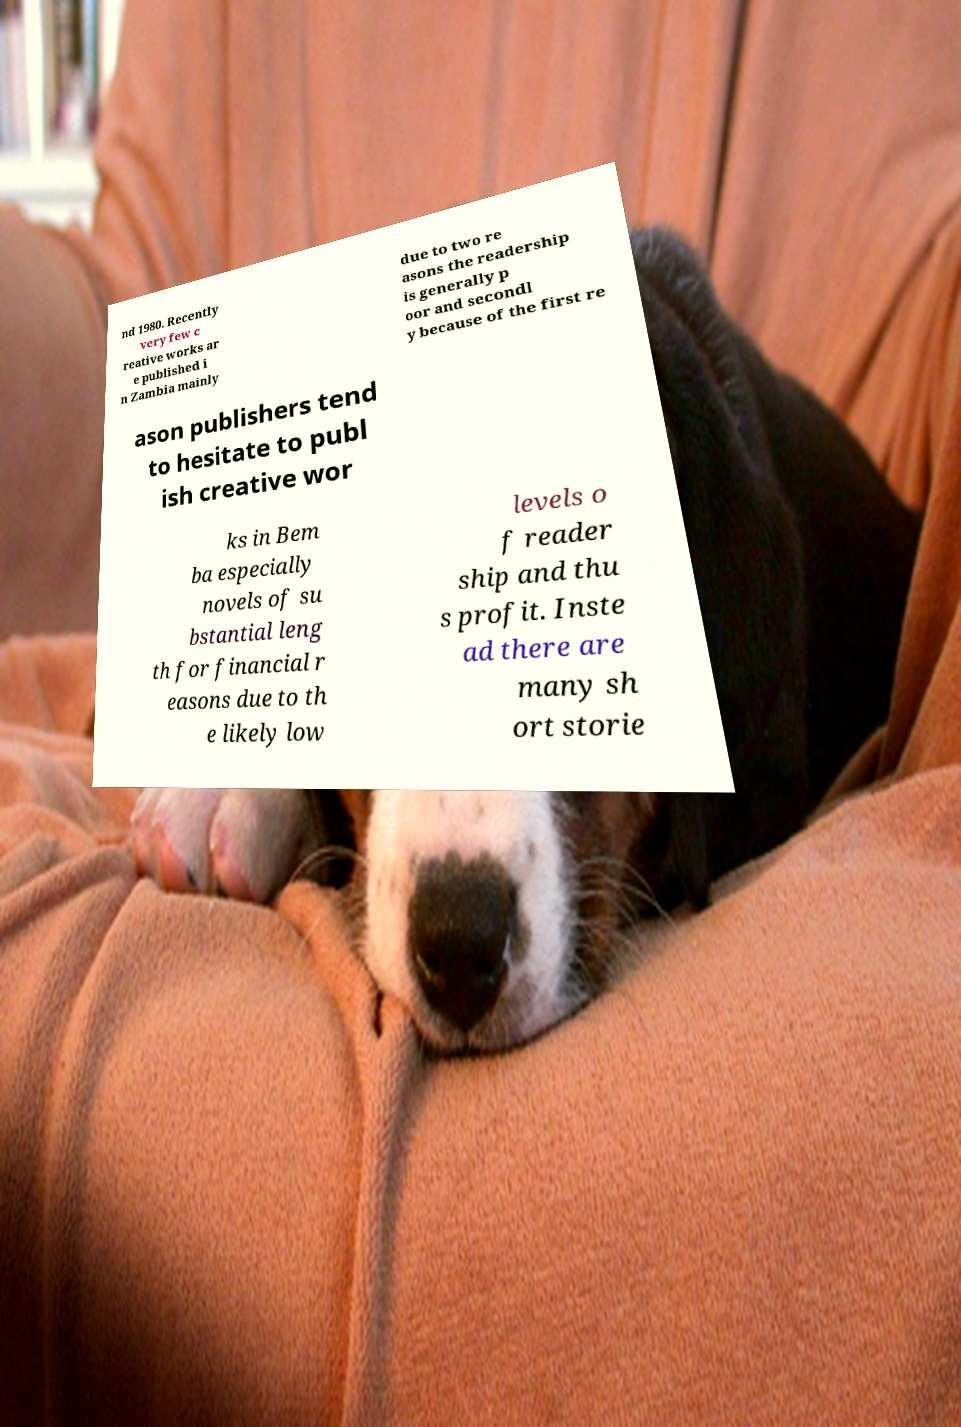Please identify and transcribe the text found in this image. nd 1980. Recently very few c reative works ar e published i n Zambia mainly due to two re asons the readership is generally p oor and secondl y because of the first re ason publishers tend to hesitate to publ ish creative wor ks in Bem ba especially novels of su bstantial leng th for financial r easons due to th e likely low levels o f reader ship and thu s profit. Inste ad there are many sh ort storie 